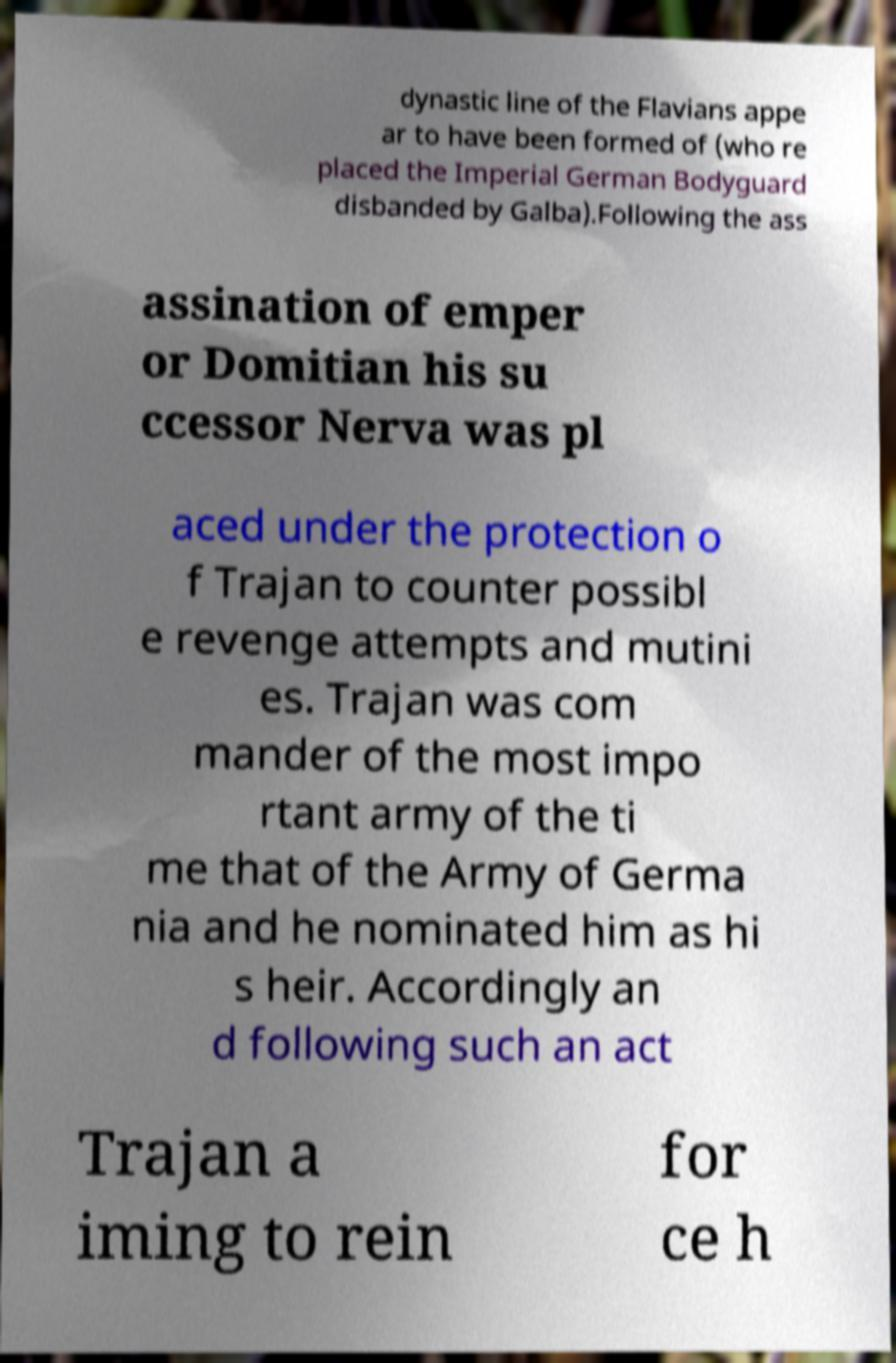For documentation purposes, I need the text within this image transcribed. Could you provide that? dynastic line of the Flavians appe ar to have been formed of (who re placed the Imperial German Bodyguard disbanded by Galba).Following the ass assination of emper or Domitian his su ccessor Nerva was pl aced under the protection o f Trajan to counter possibl e revenge attempts and mutini es. Trajan was com mander of the most impo rtant army of the ti me that of the Army of Germa nia and he nominated him as hi s heir. Accordingly an d following such an act Trajan a iming to rein for ce h 